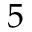<formula> <loc_0><loc_0><loc_500><loc_500>5</formula> 